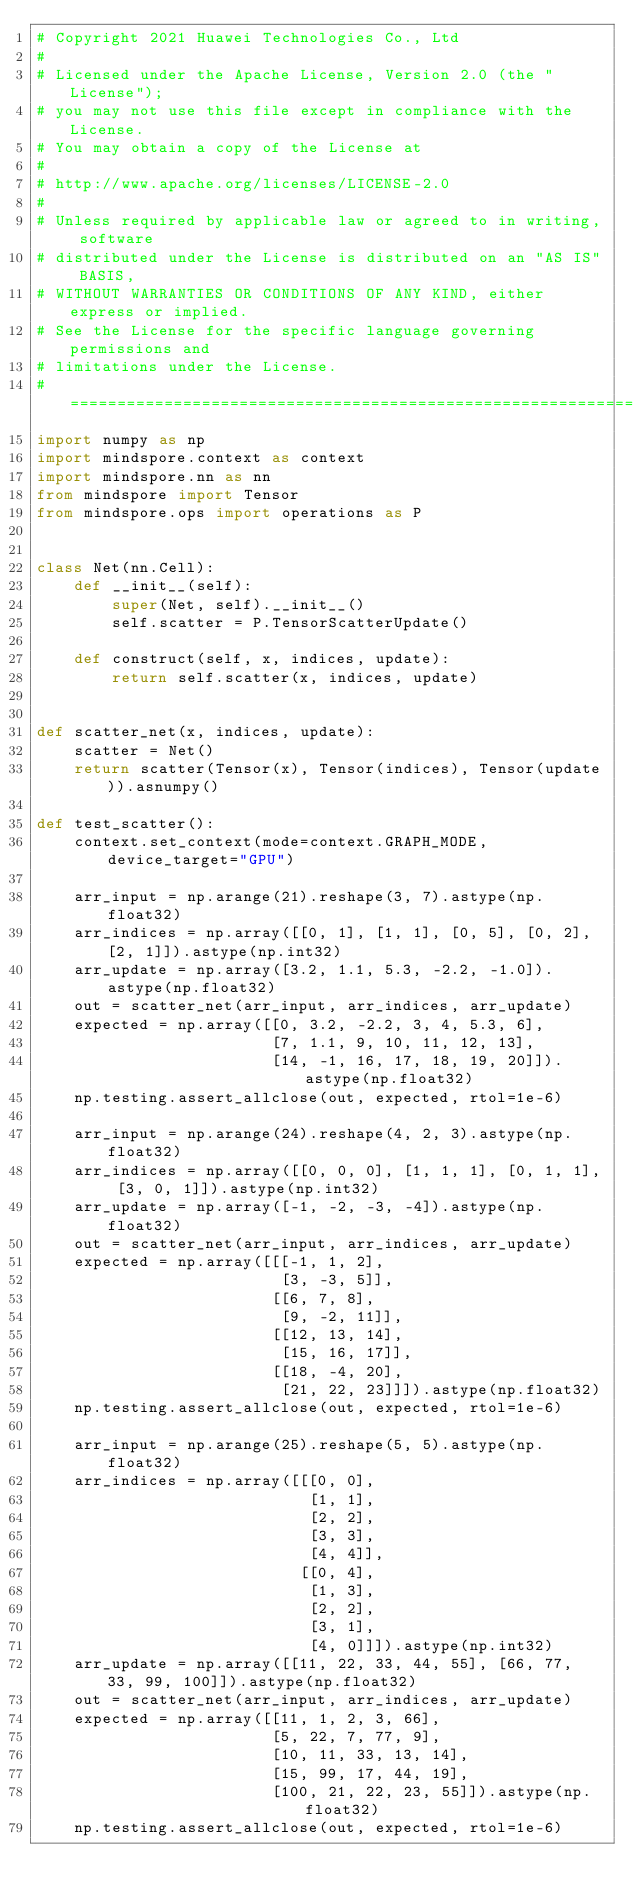<code> <loc_0><loc_0><loc_500><loc_500><_Python_># Copyright 2021 Huawei Technologies Co., Ltd
#
# Licensed under the Apache License, Version 2.0 (the "License");
# you may not use this file except in compliance with the License.
# You may obtain a copy of the License at
#
# http://www.apache.org/licenses/LICENSE-2.0
#
# Unless required by applicable law or agreed to in writing, software
# distributed under the License is distributed on an "AS IS" BASIS,
# WITHOUT WARRANTIES OR CONDITIONS OF ANY KIND, either express or implied.
# See the License for the specific language governing permissions and
# limitations under the License.
# ============================================================================
import numpy as np
import mindspore.context as context
import mindspore.nn as nn
from mindspore import Tensor
from mindspore.ops import operations as P


class Net(nn.Cell):
    def __init__(self):
        super(Net, self).__init__()
        self.scatter = P.TensorScatterUpdate()

    def construct(self, x, indices, update):
        return self.scatter(x, indices, update)


def scatter_net(x, indices, update):
    scatter = Net()
    return scatter(Tensor(x), Tensor(indices), Tensor(update)).asnumpy()

def test_scatter():
    context.set_context(mode=context.GRAPH_MODE, device_target="GPU")

    arr_input = np.arange(21).reshape(3, 7).astype(np.float32)
    arr_indices = np.array([[0, 1], [1, 1], [0, 5], [0, 2], [2, 1]]).astype(np.int32)
    arr_update = np.array([3.2, 1.1, 5.3, -2.2, -1.0]).astype(np.float32)
    out = scatter_net(arr_input, arr_indices, arr_update)
    expected = np.array([[0, 3.2, -2.2, 3, 4, 5.3, 6],
                         [7, 1.1, 9, 10, 11, 12, 13],
                         [14, -1, 16, 17, 18, 19, 20]]).astype(np.float32)
    np.testing.assert_allclose(out, expected, rtol=1e-6)

    arr_input = np.arange(24).reshape(4, 2, 3).astype(np.float32)
    arr_indices = np.array([[0, 0, 0], [1, 1, 1], [0, 1, 1], [3, 0, 1]]).astype(np.int32)
    arr_update = np.array([-1, -2, -3, -4]).astype(np.float32)
    out = scatter_net(arr_input, arr_indices, arr_update)
    expected = np.array([[[-1, 1, 2],
                          [3, -3, 5]],
                         [[6, 7, 8],
                          [9, -2, 11]],
                         [[12, 13, 14],
                          [15, 16, 17]],
                         [[18, -4, 20],
                          [21, 22, 23]]]).astype(np.float32)
    np.testing.assert_allclose(out, expected, rtol=1e-6)

    arr_input = np.arange(25).reshape(5, 5).astype(np.float32)
    arr_indices = np.array([[[0, 0],
                             [1, 1],
                             [2, 2],
                             [3, 3],
                             [4, 4]],
                            [[0, 4],
                             [1, 3],
                             [2, 2],
                             [3, 1],
                             [4, 0]]]).astype(np.int32)
    arr_update = np.array([[11, 22, 33, 44, 55], [66, 77, 33, 99, 100]]).astype(np.float32)
    out = scatter_net(arr_input, arr_indices, arr_update)
    expected = np.array([[11, 1, 2, 3, 66],
                         [5, 22, 7, 77, 9],
                         [10, 11, 33, 13, 14],
                         [15, 99, 17, 44, 19],
                         [100, 21, 22, 23, 55]]).astype(np.float32)
    np.testing.assert_allclose(out, expected, rtol=1e-6)
</code> 